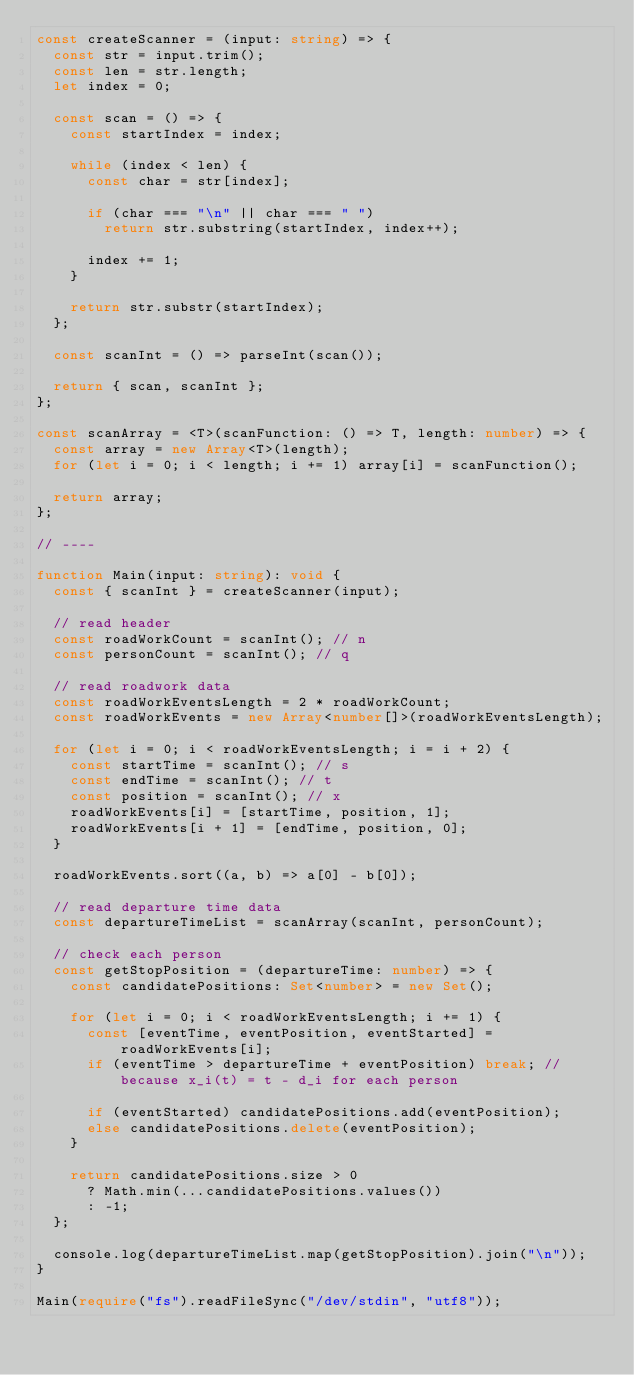Convert code to text. <code><loc_0><loc_0><loc_500><loc_500><_TypeScript_>const createScanner = (input: string) => {
  const str = input.trim();
  const len = str.length;
  let index = 0;

  const scan = () => {
    const startIndex = index;

    while (index < len) {
      const char = str[index];

      if (char === "\n" || char === " ")
        return str.substring(startIndex, index++);

      index += 1;
    }

    return str.substr(startIndex);
  };

  const scanInt = () => parseInt(scan());

  return { scan, scanInt };
};

const scanArray = <T>(scanFunction: () => T, length: number) => {
  const array = new Array<T>(length);
  for (let i = 0; i < length; i += 1) array[i] = scanFunction();

  return array;
};

// ----

function Main(input: string): void {
  const { scanInt } = createScanner(input);

  // read header
  const roadWorkCount = scanInt(); // n
  const personCount = scanInt(); // q

  // read roadwork data
  const roadWorkEventsLength = 2 * roadWorkCount;
  const roadWorkEvents = new Array<number[]>(roadWorkEventsLength);

  for (let i = 0; i < roadWorkEventsLength; i = i + 2) {
    const startTime = scanInt(); // s
    const endTime = scanInt(); // t
    const position = scanInt(); // x
    roadWorkEvents[i] = [startTime, position, 1];
    roadWorkEvents[i + 1] = [endTime, position, 0];
  }

  roadWorkEvents.sort((a, b) => a[0] - b[0]);

  // read departure time data
  const departureTimeList = scanArray(scanInt, personCount);

  // check each person
  const getStopPosition = (departureTime: number) => {
    const candidatePositions: Set<number> = new Set();

    for (let i = 0; i < roadWorkEventsLength; i += 1) {
      const [eventTime, eventPosition, eventStarted] = roadWorkEvents[i];
      if (eventTime > departureTime + eventPosition) break; // because x_i(t) = t - d_i for each person

      if (eventStarted) candidatePositions.add(eventPosition);
      else candidatePositions.delete(eventPosition);
    }

    return candidatePositions.size > 0
      ? Math.min(...candidatePositions.values())
      : -1;
  };

  console.log(departureTimeList.map(getStopPosition).join("\n"));
}

Main(require("fs").readFileSync("/dev/stdin", "utf8"));
</code> 